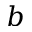<formula> <loc_0><loc_0><loc_500><loc_500>b</formula> 